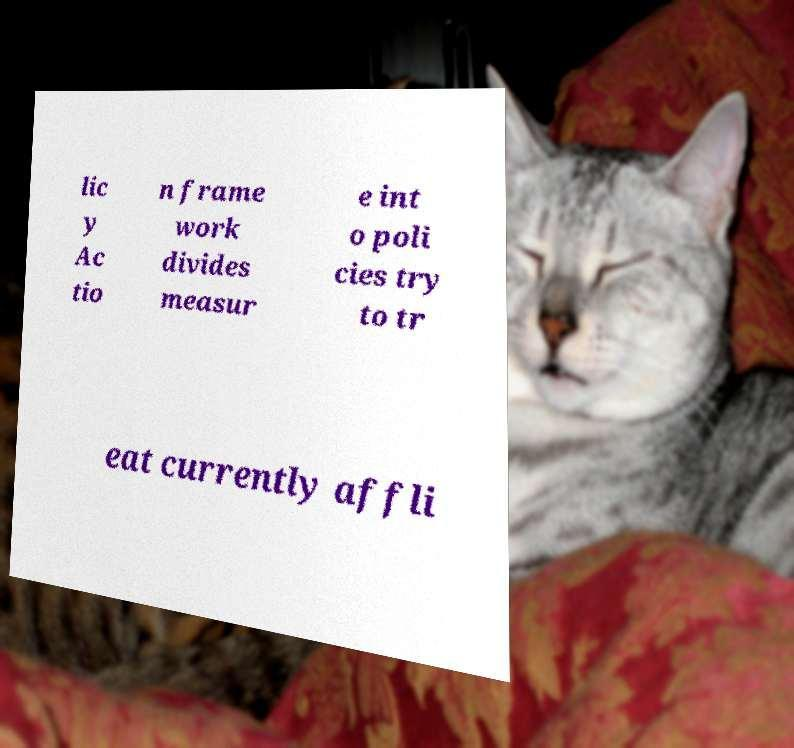Can you accurately transcribe the text from the provided image for me? lic y Ac tio n frame work divides measur e int o poli cies try to tr eat currently affli 